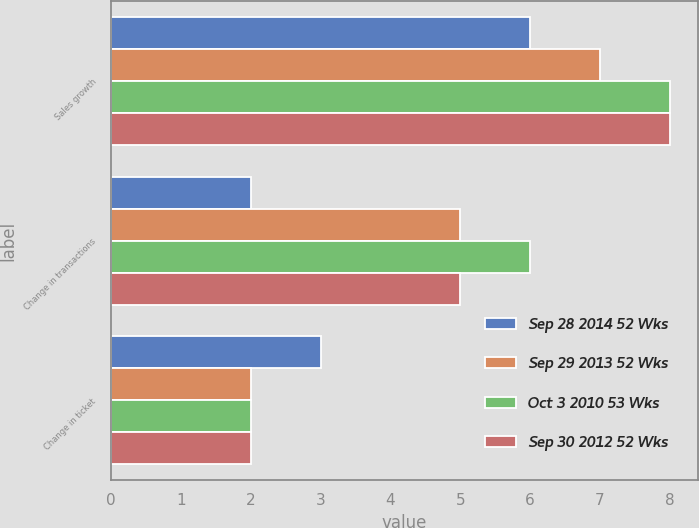<chart> <loc_0><loc_0><loc_500><loc_500><stacked_bar_chart><ecel><fcel>Sales growth<fcel>Change in transactions<fcel>Change in ticket<nl><fcel>Sep 28 2014 52 Wks<fcel>6<fcel>2<fcel>3<nl><fcel>Sep 29 2013 52 Wks<fcel>7<fcel>5<fcel>2<nl><fcel>Oct 3 2010 53 Wks<fcel>8<fcel>6<fcel>2<nl><fcel>Sep 30 2012 52 Wks<fcel>8<fcel>5<fcel>2<nl></chart> 